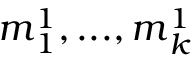Convert formula to latex. <formula><loc_0><loc_0><loc_500><loc_500>m _ { 1 } ^ { 1 } , \dots , m _ { k } ^ { 1 }</formula> 